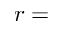<formula> <loc_0><loc_0><loc_500><loc_500>r =</formula> 